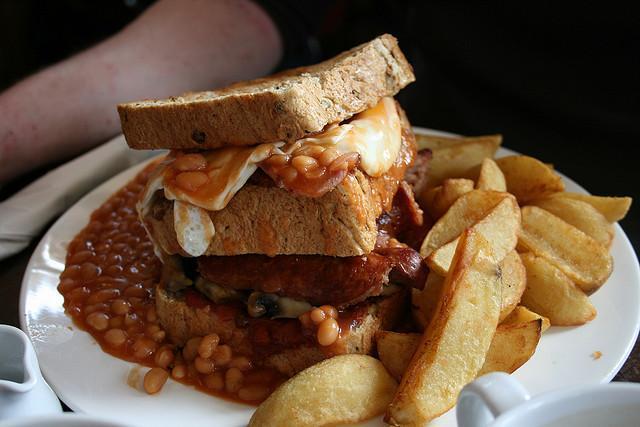How many blue keyboards are there?
Give a very brief answer. 0. 